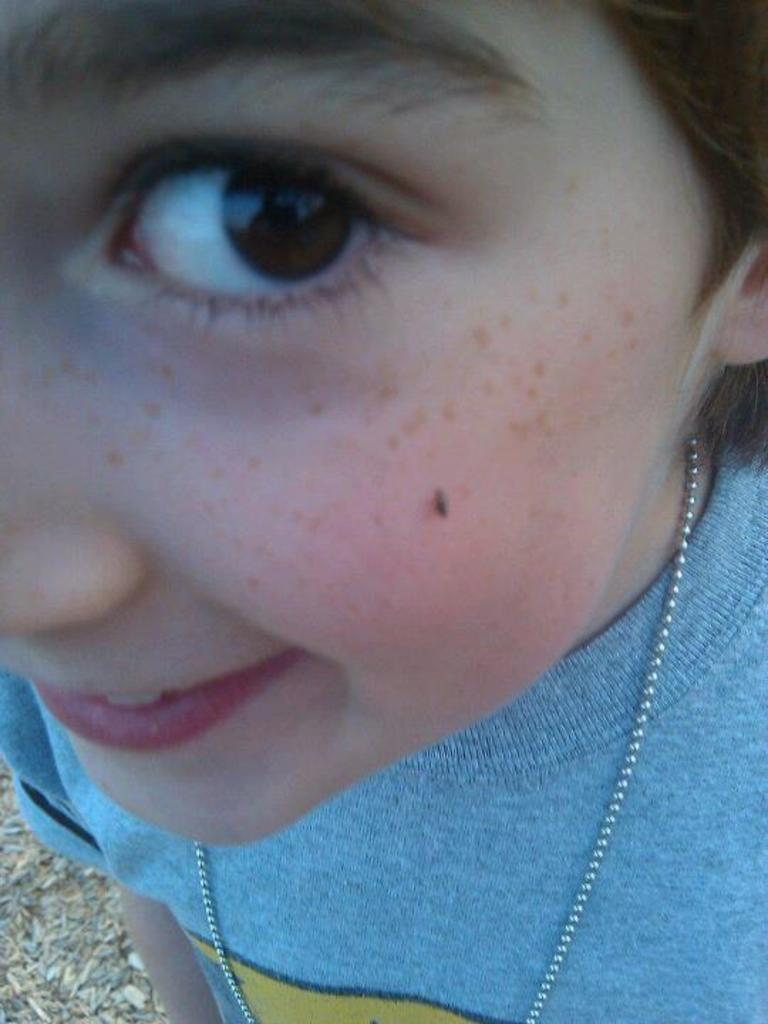What is the main subject of the image? There is a person in the image. What is the person doing in the image? The person is standing in the image. What is the person's facial expression in the image? The person is smiling in the image. What type of boat can be seen in the image? There is no boat present in the image; it features a person standing and smiling. What unit of measurement is used to describe the person's height in the image? There is no measurement provided in the image, and the person's height is not relevant to the description. 